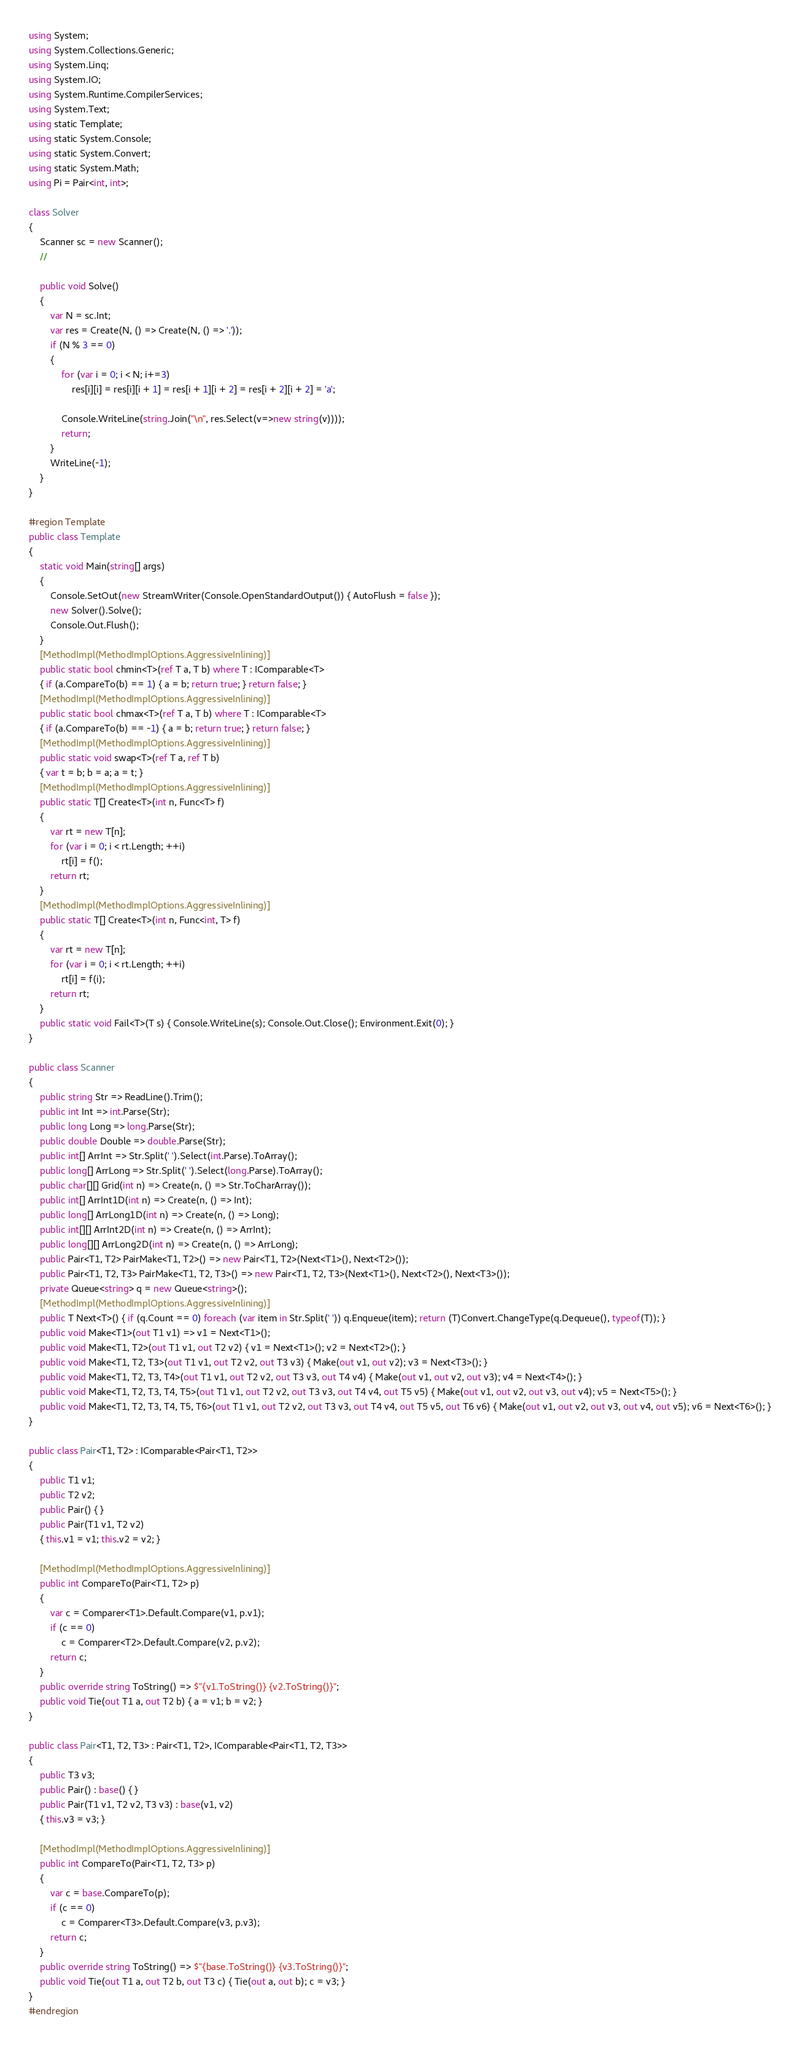<code> <loc_0><loc_0><loc_500><loc_500><_C#_>using System;
using System.Collections.Generic;
using System.Linq;
using System.IO;
using System.Runtime.CompilerServices;
using System.Text;
using static Template;
using static System.Console;
using static System.Convert;
using static System.Math;
using Pi = Pair<int, int>;

class Solver
{
    Scanner sc = new Scanner();
    //

    public void Solve()
    {
        var N = sc.Int;
        var res = Create(N, () => Create(N, () => '.'));
        if (N % 3 == 0)
        {
            for (var i = 0; i < N; i+=3)
                res[i][i] = res[i][i + 1] = res[i + 1][i + 2] = res[i + 2][i + 2] = 'a';

            Console.WriteLine(string.Join("\n", res.Select(v=>new string(v))));
            return;
        }
        WriteLine(-1);
    }
}

#region Template
public class Template
{
    static void Main(string[] args)
    {
        Console.SetOut(new StreamWriter(Console.OpenStandardOutput()) { AutoFlush = false });
        new Solver().Solve();
        Console.Out.Flush();
    }
    [MethodImpl(MethodImplOptions.AggressiveInlining)]
    public static bool chmin<T>(ref T a, T b) where T : IComparable<T>
    { if (a.CompareTo(b) == 1) { a = b; return true; } return false; }
    [MethodImpl(MethodImplOptions.AggressiveInlining)]
    public static bool chmax<T>(ref T a, T b) where T : IComparable<T>
    { if (a.CompareTo(b) == -1) { a = b; return true; } return false; }
    [MethodImpl(MethodImplOptions.AggressiveInlining)]
    public static void swap<T>(ref T a, ref T b)
    { var t = b; b = a; a = t; }
    [MethodImpl(MethodImplOptions.AggressiveInlining)]
    public static T[] Create<T>(int n, Func<T> f)
    {
        var rt = new T[n];
        for (var i = 0; i < rt.Length; ++i)
            rt[i] = f();
        return rt;
    }
    [MethodImpl(MethodImplOptions.AggressiveInlining)]
    public static T[] Create<T>(int n, Func<int, T> f)
    {
        var rt = new T[n];
        for (var i = 0; i < rt.Length; ++i)
            rt[i] = f(i);
        return rt;
    }
    public static void Fail<T>(T s) { Console.WriteLine(s); Console.Out.Close(); Environment.Exit(0); }
}

public class Scanner
{
    public string Str => ReadLine().Trim();
    public int Int => int.Parse(Str);
    public long Long => long.Parse(Str);
    public double Double => double.Parse(Str);
    public int[] ArrInt => Str.Split(' ').Select(int.Parse).ToArray();
    public long[] ArrLong => Str.Split(' ').Select(long.Parse).ToArray();
    public char[][] Grid(int n) => Create(n, () => Str.ToCharArray());
    public int[] ArrInt1D(int n) => Create(n, () => Int);
    public long[] ArrLong1D(int n) => Create(n, () => Long);
    public int[][] ArrInt2D(int n) => Create(n, () => ArrInt);
    public long[][] ArrLong2D(int n) => Create(n, () => ArrLong);
    public Pair<T1, T2> PairMake<T1, T2>() => new Pair<T1, T2>(Next<T1>(), Next<T2>());
    public Pair<T1, T2, T3> PairMake<T1, T2, T3>() => new Pair<T1, T2, T3>(Next<T1>(), Next<T2>(), Next<T3>());
    private Queue<string> q = new Queue<string>();
    [MethodImpl(MethodImplOptions.AggressiveInlining)]
    public T Next<T>() { if (q.Count == 0) foreach (var item in Str.Split(' ')) q.Enqueue(item); return (T)Convert.ChangeType(q.Dequeue(), typeof(T)); }
    public void Make<T1>(out T1 v1) => v1 = Next<T1>();
    public void Make<T1, T2>(out T1 v1, out T2 v2) { v1 = Next<T1>(); v2 = Next<T2>(); }
    public void Make<T1, T2, T3>(out T1 v1, out T2 v2, out T3 v3) { Make(out v1, out v2); v3 = Next<T3>(); }
    public void Make<T1, T2, T3, T4>(out T1 v1, out T2 v2, out T3 v3, out T4 v4) { Make(out v1, out v2, out v3); v4 = Next<T4>(); }
    public void Make<T1, T2, T3, T4, T5>(out T1 v1, out T2 v2, out T3 v3, out T4 v4, out T5 v5) { Make(out v1, out v2, out v3, out v4); v5 = Next<T5>(); }
    public void Make<T1, T2, T3, T4, T5, T6>(out T1 v1, out T2 v2, out T3 v3, out T4 v4, out T5 v5, out T6 v6) { Make(out v1, out v2, out v3, out v4, out v5); v6 = Next<T6>(); }
}

public class Pair<T1, T2> : IComparable<Pair<T1, T2>>
{
    public T1 v1;
    public T2 v2;
    public Pair() { }
    public Pair(T1 v1, T2 v2)
    { this.v1 = v1; this.v2 = v2; }

    [MethodImpl(MethodImplOptions.AggressiveInlining)]
    public int CompareTo(Pair<T1, T2> p)
    {
        var c = Comparer<T1>.Default.Compare(v1, p.v1);
        if (c == 0)
            c = Comparer<T2>.Default.Compare(v2, p.v2);
        return c;
    }
    public override string ToString() => $"{v1.ToString()} {v2.ToString()}";
    public void Tie(out T1 a, out T2 b) { a = v1; b = v2; }
}

public class Pair<T1, T2, T3> : Pair<T1, T2>, IComparable<Pair<T1, T2, T3>>
{
    public T3 v3;
    public Pair() : base() { }
    public Pair(T1 v1, T2 v2, T3 v3) : base(v1, v2)
    { this.v3 = v3; }

    [MethodImpl(MethodImplOptions.AggressiveInlining)]
    public int CompareTo(Pair<T1, T2, T3> p)
    {
        var c = base.CompareTo(p);
        if (c == 0)
            c = Comparer<T3>.Default.Compare(v3, p.v3);
        return c;
    }
    public override string ToString() => $"{base.ToString()} {v3.ToString()}";
    public void Tie(out T1 a, out T2 b, out T3 c) { Tie(out a, out b); c = v3; }
}
#endregion
</code> 